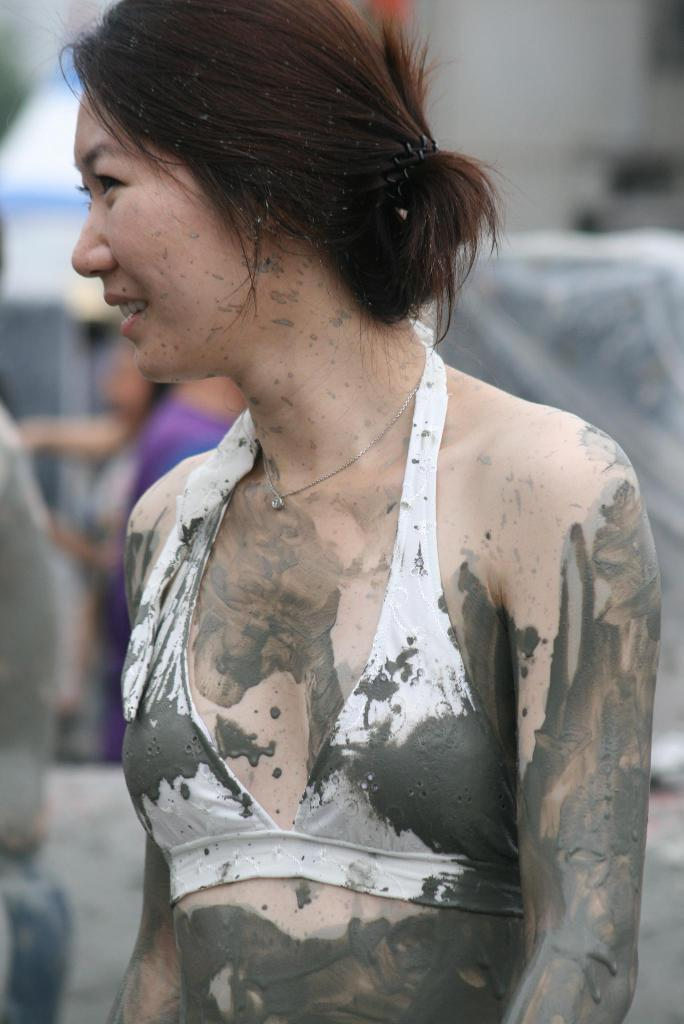What is the main subject of the image? There is a woman in the image. What is the woman wearing? The woman is wearing a white bikini. What is covering the woman's body in the image? There is mud all over the woman. Can you describe the background of the image? The background of the image is blurry. What type of coat is the woman wearing in the image? There is no coat present in the image; the woman is wearing a white bikini and is covered in mud. What kind of fowl can be seen in the image? There is no fowl present in the image; it features a woman covered in mud and wearing a white bikini. 